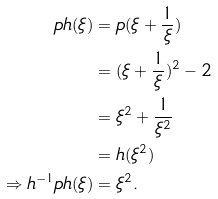Convert formula to latex. <formula><loc_0><loc_0><loc_500><loc_500>p h ( \xi ) & = p ( \xi + \frac { 1 } { \xi } ) \\ & = ( \xi + \frac { 1 } { \xi } ) ^ { 2 } - 2 \\ & = \xi ^ { 2 } + \frac { 1 } { \xi ^ { 2 } } \\ & = h ( \xi ^ { 2 } ) \\ \Rightarrow h ^ { - 1 } p h ( \xi ) & = \xi ^ { 2 } .</formula> 